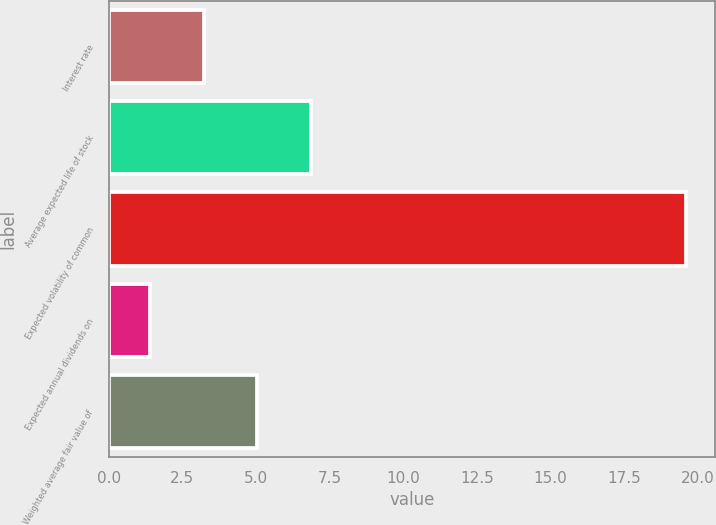Convert chart to OTSL. <chart><loc_0><loc_0><loc_500><loc_500><bar_chart><fcel>Interest rate<fcel>Average expected life of stock<fcel>Expected volatility of common<fcel>Expected annual dividends on<fcel>Weighted average fair value of<nl><fcel>3.22<fcel>6.86<fcel>19.6<fcel>1.4<fcel>5.04<nl></chart> 